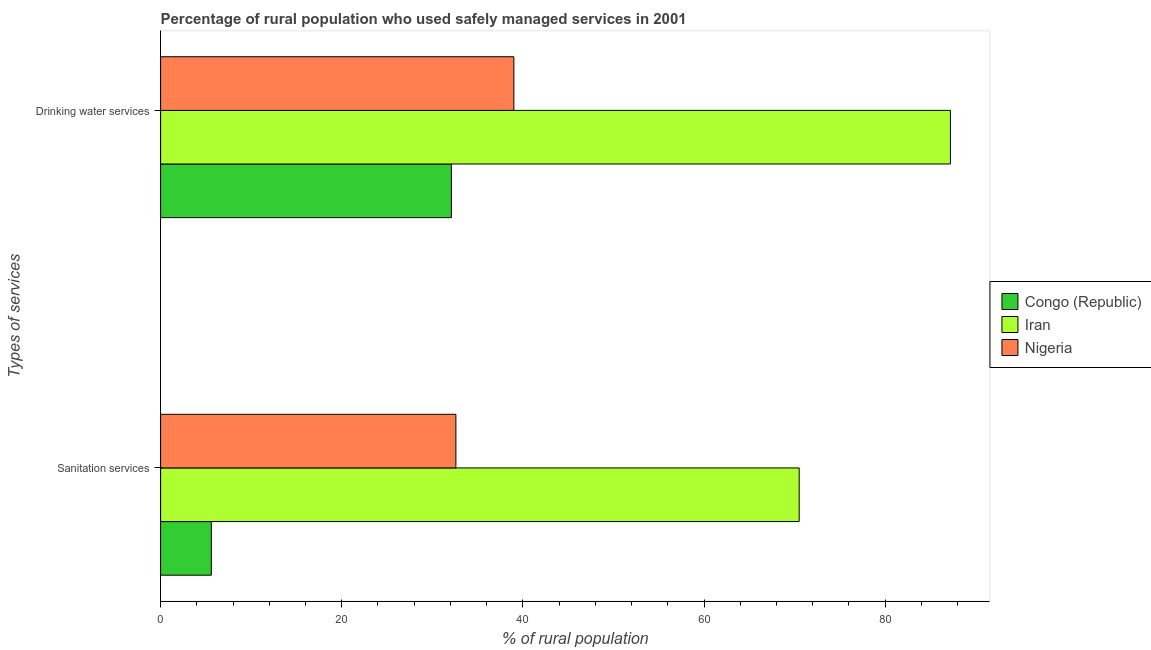How many bars are there on the 2nd tick from the top?
Your answer should be compact. 3. What is the label of the 2nd group of bars from the top?
Give a very brief answer. Sanitation services. What is the percentage of rural population who used sanitation services in Nigeria?
Ensure brevity in your answer.  32.6. Across all countries, what is the maximum percentage of rural population who used drinking water services?
Your answer should be very brief. 87.2. In which country was the percentage of rural population who used sanitation services maximum?
Provide a short and direct response. Iran. In which country was the percentage of rural population who used drinking water services minimum?
Provide a succinct answer. Congo (Republic). What is the total percentage of rural population who used sanitation services in the graph?
Offer a very short reply. 108.7. What is the difference between the percentage of rural population who used sanitation services in Iran and that in Nigeria?
Make the answer very short. 37.9. What is the difference between the percentage of rural population who used sanitation services in Iran and the percentage of rural population who used drinking water services in Congo (Republic)?
Ensure brevity in your answer.  38.4. What is the average percentage of rural population who used drinking water services per country?
Offer a terse response. 52.77. What is the difference between the percentage of rural population who used sanitation services and percentage of rural population who used drinking water services in Nigeria?
Give a very brief answer. -6.4. In how many countries, is the percentage of rural population who used sanitation services greater than 24 %?
Offer a very short reply. 2. What is the ratio of the percentage of rural population who used drinking water services in Congo (Republic) to that in Nigeria?
Make the answer very short. 0.82. In how many countries, is the percentage of rural population who used drinking water services greater than the average percentage of rural population who used drinking water services taken over all countries?
Provide a succinct answer. 1. What does the 2nd bar from the top in Sanitation services represents?
Ensure brevity in your answer.  Iran. What does the 2nd bar from the bottom in Sanitation services represents?
Your response must be concise. Iran. How many bars are there?
Offer a very short reply. 6. What is the difference between two consecutive major ticks on the X-axis?
Offer a very short reply. 20. Does the graph contain any zero values?
Your response must be concise. No. Does the graph contain grids?
Offer a terse response. No. Where does the legend appear in the graph?
Make the answer very short. Center right. How are the legend labels stacked?
Your answer should be compact. Vertical. What is the title of the graph?
Ensure brevity in your answer.  Percentage of rural population who used safely managed services in 2001. Does "United Kingdom" appear as one of the legend labels in the graph?
Your response must be concise. No. What is the label or title of the X-axis?
Your response must be concise. % of rural population. What is the label or title of the Y-axis?
Provide a short and direct response. Types of services. What is the % of rural population in Congo (Republic) in Sanitation services?
Keep it short and to the point. 5.6. What is the % of rural population of Iran in Sanitation services?
Give a very brief answer. 70.5. What is the % of rural population of Nigeria in Sanitation services?
Ensure brevity in your answer.  32.6. What is the % of rural population in Congo (Republic) in Drinking water services?
Your answer should be compact. 32.1. What is the % of rural population in Iran in Drinking water services?
Your answer should be very brief. 87.2. What is the % of rural population of Nigeria in Drinking water services?
Give a very brief answer. 39. Across all Types of services, what is the maximum % of rural population in Congo (Republic)?
Provide a short and direct response. 32.1. Across all Types of services, what is the maximum % of rural population of Iran?
Provide a short and direct response. 87.2. Across all Types of services, what is the maximum % of rural population in Nigeria?
Make the answer very short. 39. Across all Types of services, what is the minimum % of rural population of Congo (Republic)?
Keep it short and to the point. 5.6. Across all Types of services, what is the minimum % of rural population of Iran?
Provide a succinct answer. 70.5. Across all Types of services, what is the minimum % of rural population of Nigeria?
Your answer should be compact. 32.6. What is the total % of rural population of Congo (Republic) in the graph?
Give a very brief answer. 37.7. What is the total % of rural population in Iran in the graph?
Your answer should be very brief. 157.7. What is the total % of rural population in Nigeria in the graph?
Ensure brevity in your answer.  71.6. What is the difference between the % of rural population of Congo (Republic) in Sanitation services and that in Drinking water services?
Your response must be concise. -26.5. What is the difference between the % of rural population of Iran in Sanitation services and that in Drinking water services?
Provide a succinct answer. -16.7. What is the difference between the % of rural population in Congo (Republic) in Sanitation services and the % of rural population in Iran in Drinking water services?
Offer a terse response. -81.6. What is the difference between the % of rural population in Congo (Republic) in Sanitation services and the % of rural population in Nigeria in Drinking water services?
Offer a terse response. -33.4. What is the difference between the % of rural population in Iran in Sanitation services and the % of rural population in Nigeria in Drinking water services?
Keep it short and to the point. 31.5. What is the average % of rural population in Congo (Republic) per Types of services?
Give a very brief answer. 18.85. What is the average % of rural population of Iran per Types of services?
Give a very brief answer. 78.85. What is the average % of rural population in Nigeria per Types of services?
Provide a short and direct response. 35.8. What is the difference between the % of rural population in Congo (Republic) and % of rural population in Iran in Sanitation services?
Your answer should be compact. -64.9. What is the difference between the % of rural population of Congo (Republic) and % of rural population of Nigeria in Sanitation services?
Ensure brevity in your answer.  -27. What is the difference between the % of rural population in Iran and % of rural population in Nigeria in Sanitation services?
Provide a short and direct response. 37.9. What is the difference between the % of rural population of Congo (Republic) and % of rural population of Iran in Drinking water services?
Offer a terse response. -55.1. What is the difference between the % of rural population of Iran and % of rural population of Nigeria in Drinking water services?
Provide a short and direct response. 48.2. What is the ratio of the % of rural population of Congo (Republic) in Sanitation services to that in Drinking water services?
Ensure brevity in your answer.  0.17. What is the ratio of the % of rural population in Iran in Sanitation services to that in Drinking water services?
Keep it short and to the point. 0.81. What is the ratio of the % of rural population in Nigeria in Sanitation services to that in Drinking water services?
Ensure brevity in your answer.  0.84. What is the difference between the highest and the second highest % of rural population of Congo (Republic)?
Offer a very short reply. 26.5. What is the difference between the highest and the second highest % of rural population of Iran?
Offer a terse response. 16.7. What is the difference between the highest and the lowest % of rural population of Congo (Republic)?
Your answer should be compact. 26.5. 